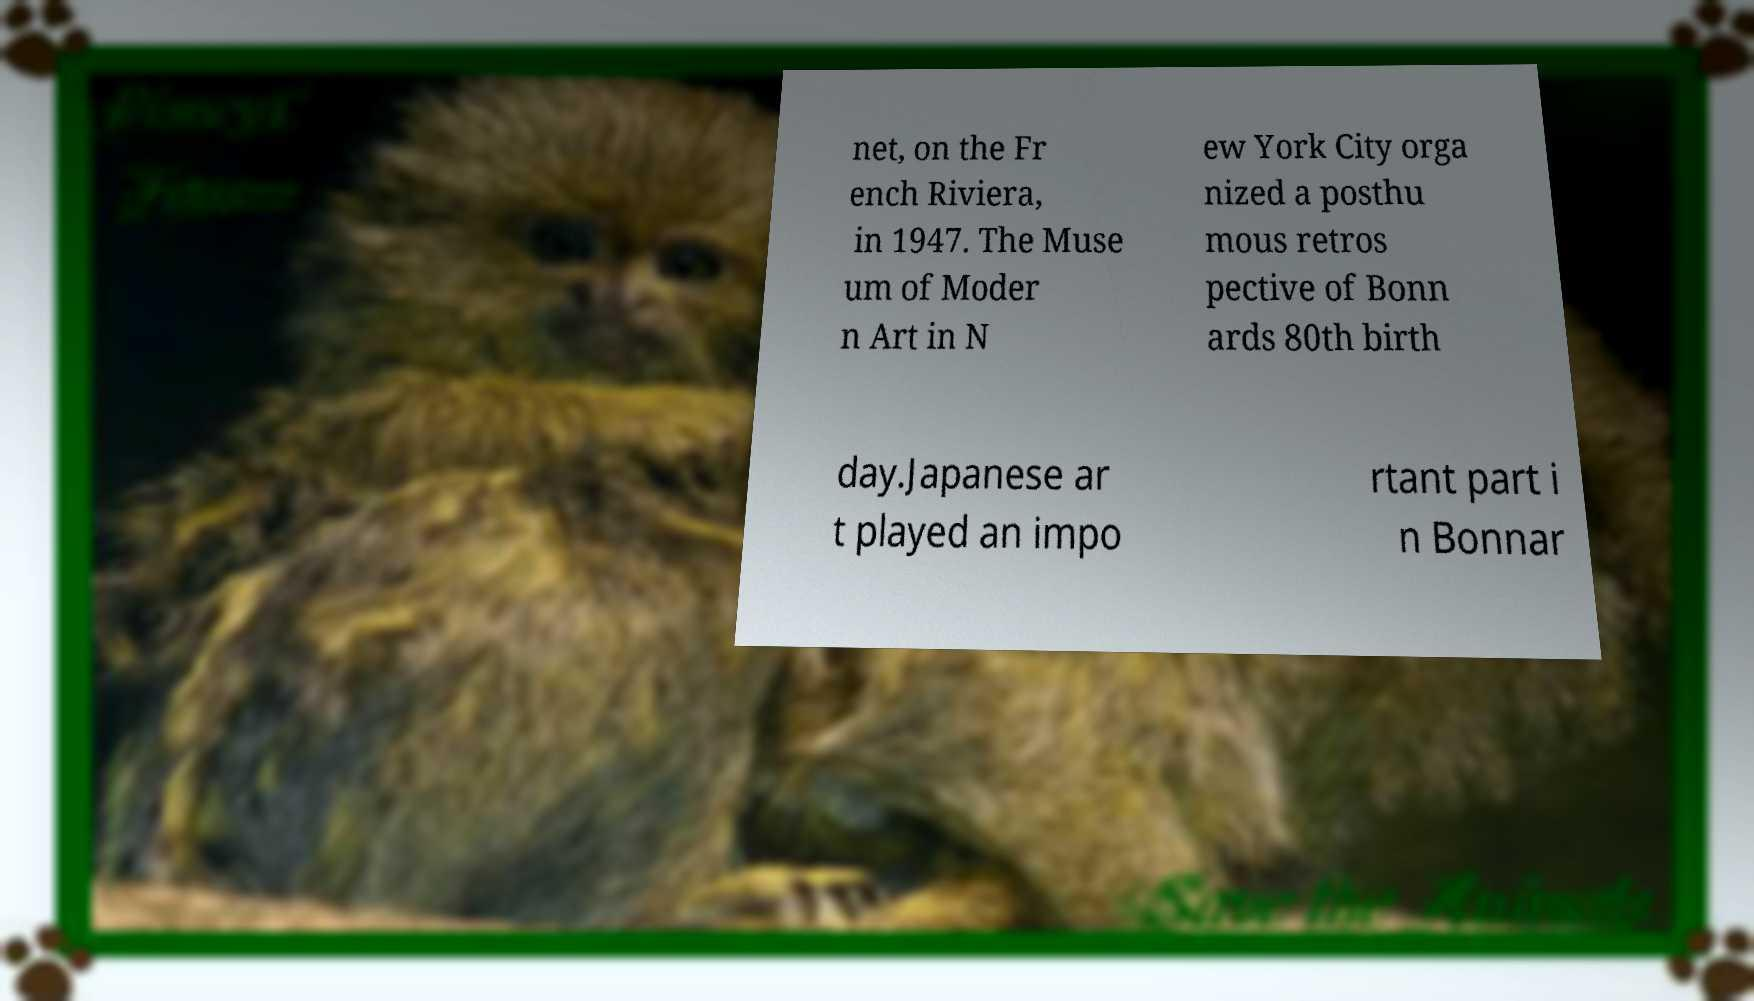Could you extract and type out the text from this image? net, on the Fr ench Riviera, in 1947. The Muse um of Moder n Art in N ew York City orga nized a posthu mous retros pective of Bonn ards 80th birth day.Japanese ar t played an impo rtant part i n Bonnar 